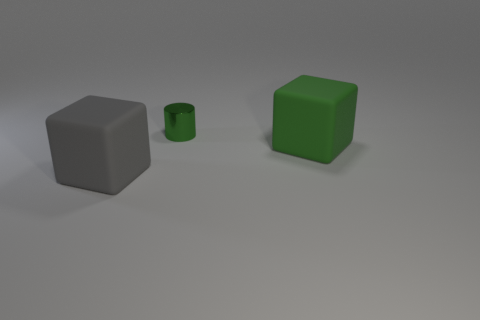Add 2 yellow matte cubes. How many objects exist? 5 Subtract all cylinders. How many objects are left? 2 Add 2 small metal things. How many small metal things exist? 3 Subtract 1 gray cubes. How many objects are left? 2 Subtract all large gray blocks. Subtract all small green shiny cylinders. How many objects are left? 1 Add 3 cylinders. How many cylinders are left? 4 